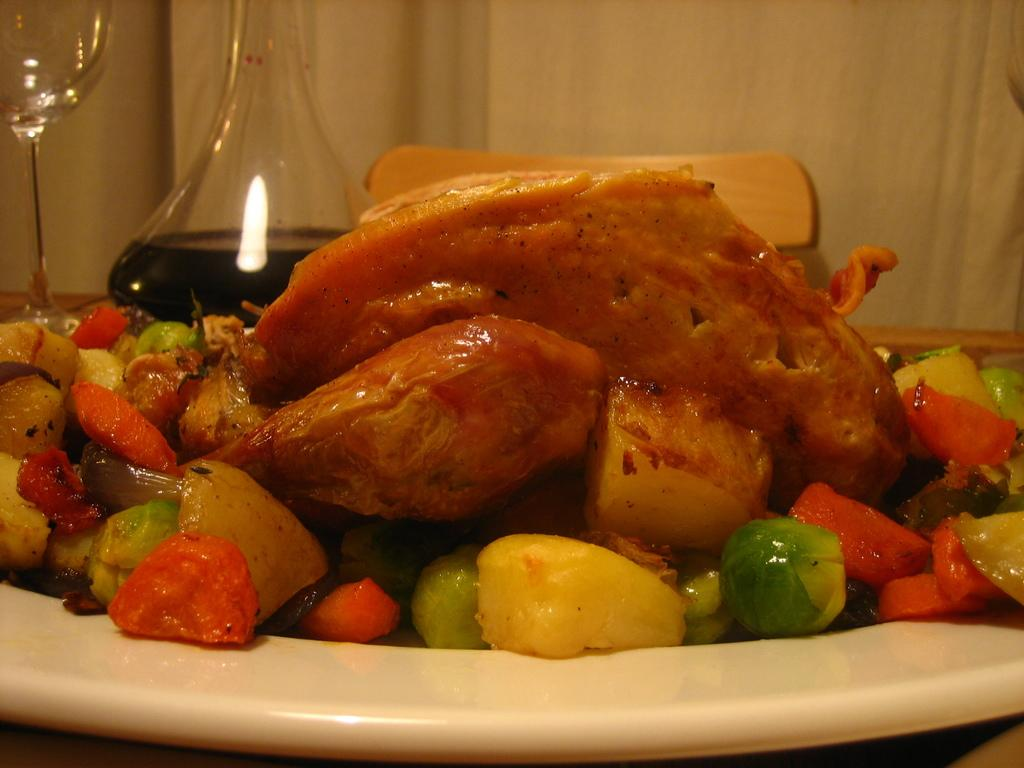What type of cooked food can be seen in the image? There is a cooked food item in the image, but the specific type is not mentioned. What else is served on a plate in the image? There are boiled vegetables served on a plate in the image. What color is the collar of the baseball player in the image? There is no baseball player or collar present in the image. How many cubs are visible in the image? There are no cubs present in the image. 